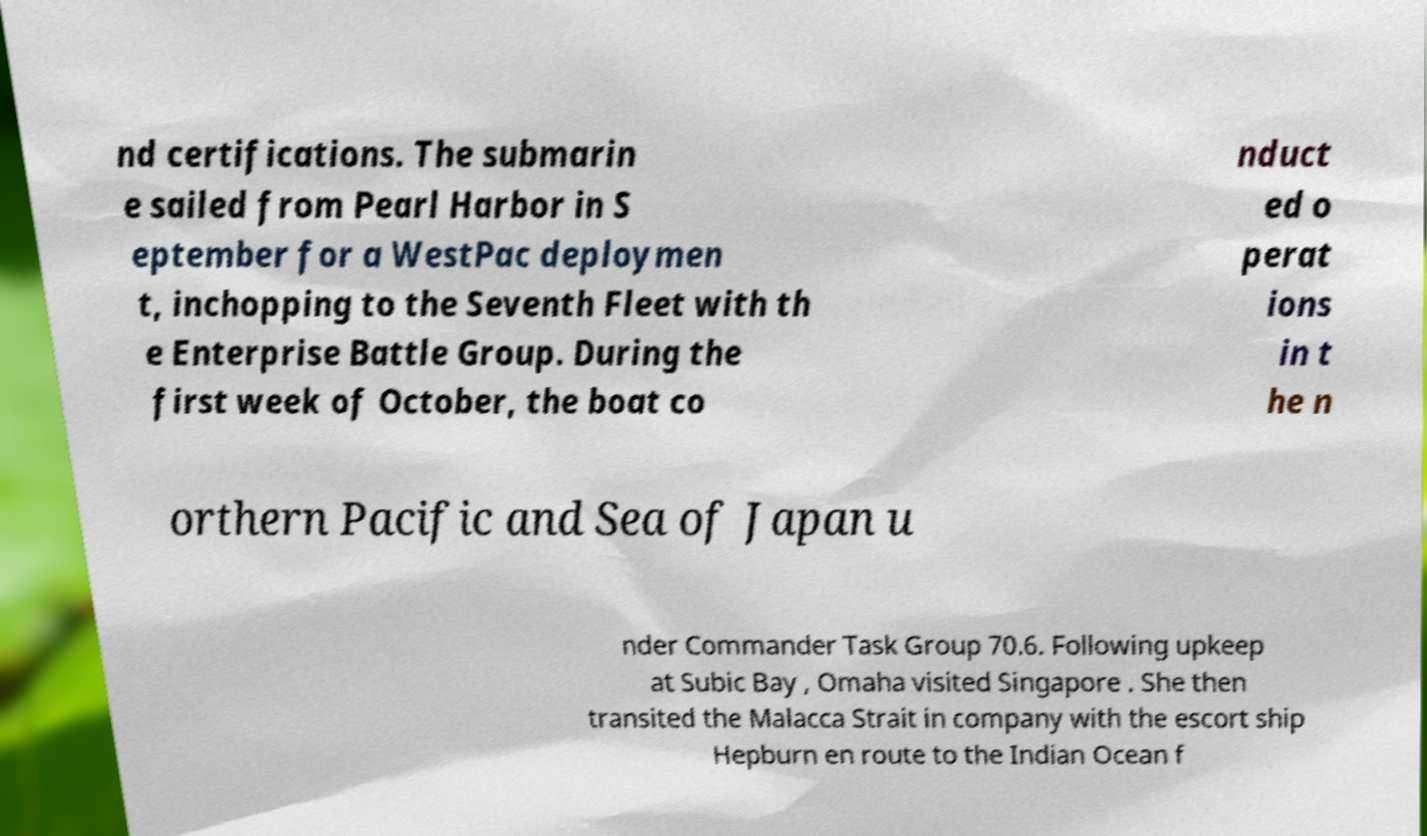I need the written content from this picture converted into text. Can you do that? nd certifications. The submarin e sailed from Pearl Harbor in S eptember for a WestPac deploymen t, inchopping to the Seventh Fleet with th e Enterprise Battle Group. During the first week of October, the boat co nduct ed o perat ions in t he n orthern Pacific and Sea of Japan u nder Commander Task Group 70.6. Following upkeep at Subic Bay , Omaha visited Singapore . She then transited the Malacca Strait in company with the escort ship Hepburn en route to the Indian Ocean f 